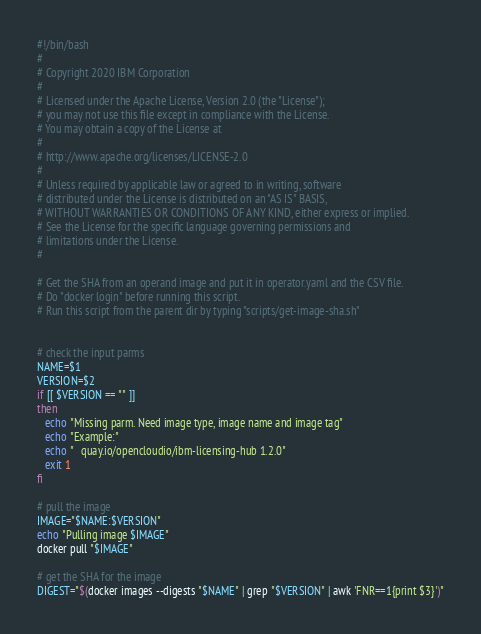Convert code to text. <code><loc_0><loc_0><loc_500><loc_500><_Bash_>#!/bin/bash
#
# Copyright 2020 IBM Corporation
#
# Licensed under the Apache License, Version 2.0 (the "License");
# you may not use this file except in compliance with the License.
# You may obtain a copy of the License at
#
# http://www.apache.org/licenses/LICENSE-2.0
#
# Unless required by applicable law or agreed to in writing, software
# distributed under the License is distributed on an "AS IS" BASIS,
# WITHOUT WARRANTIES OR CONDITIONS OF ANY KIND, either express or implied.
# See the License for the specific language governing permissions and
# limitations under the License.
#

# Get the SHA from an operand image and put it in operator.yaml and the CSV file.
# Do "docker login" before running this script.
# Run this script from the parent dir by typing "scripts/get-image-sha.sh"


# check the input parms
NAME=$1
VERSION=$2
if [[ $VERSION == "" ]]
then
   echo "Missing parm. Need image type, image name and image tag"
   echo "Example:"
   echo "   quay.io/opencloudio/ibm-licensing-hub 1.2.0"
   exit 1
fi

# pull the image
IMAGE="$NAME:$VERSION"
echo "Pulling image $IMAGE"
docker pull "$IMAGE"

# get the SHA for the image
DIGEST="$(docker images --digests "$NAME" | grep "$VERSION" | awk 'FNR==1{print $3}')"
</code> 